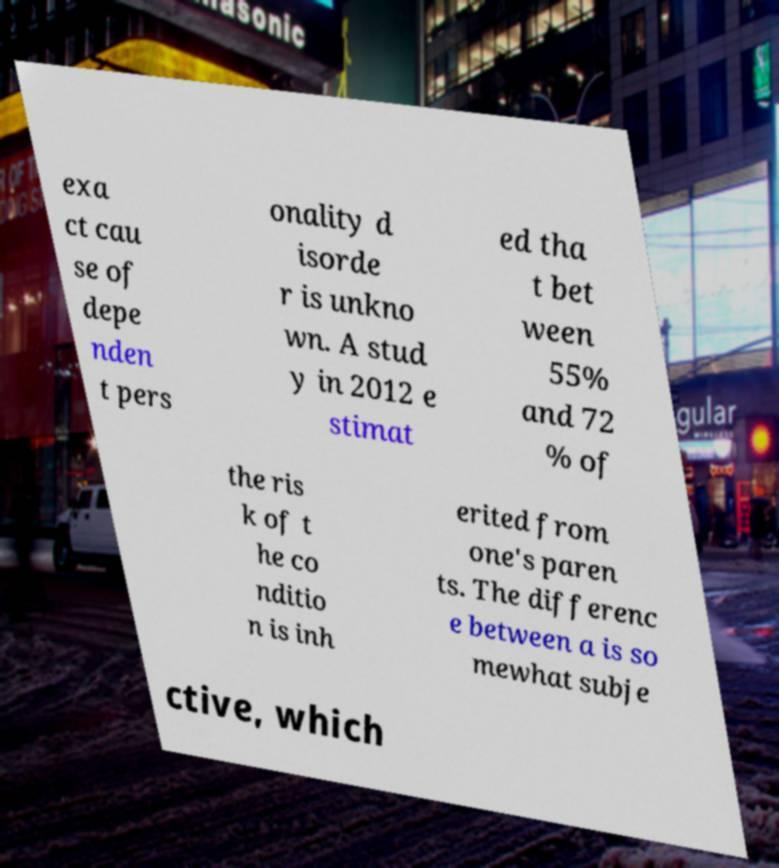Could you assist in decoding the text presented in this image and type it out clearly? exa ct cau se of depe nden t pers onality d isorde r is unkno wn. A stud y in 2012 e stimat ed tha t bet ween 55% and 72 % of the ris k of t he co nditio n is inh erited from one's paren ts. The differenc e between a is so mewhat subje ctive, which 